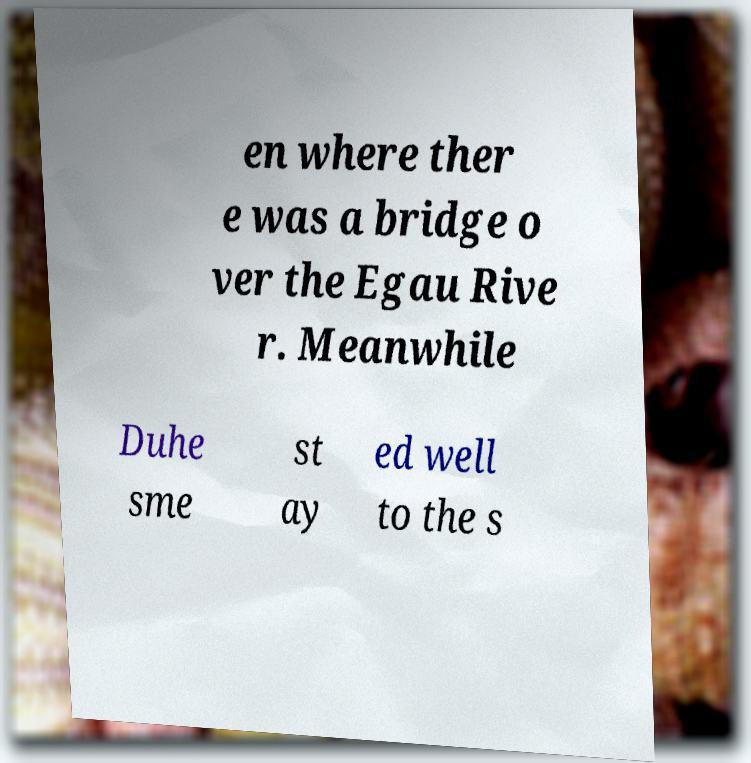Please read and relay the text visible in this image. What does it say? en where ther e was a bridge o ver the Egau Rive r. Meanwhile Duhe sme st ay ed well to the s 